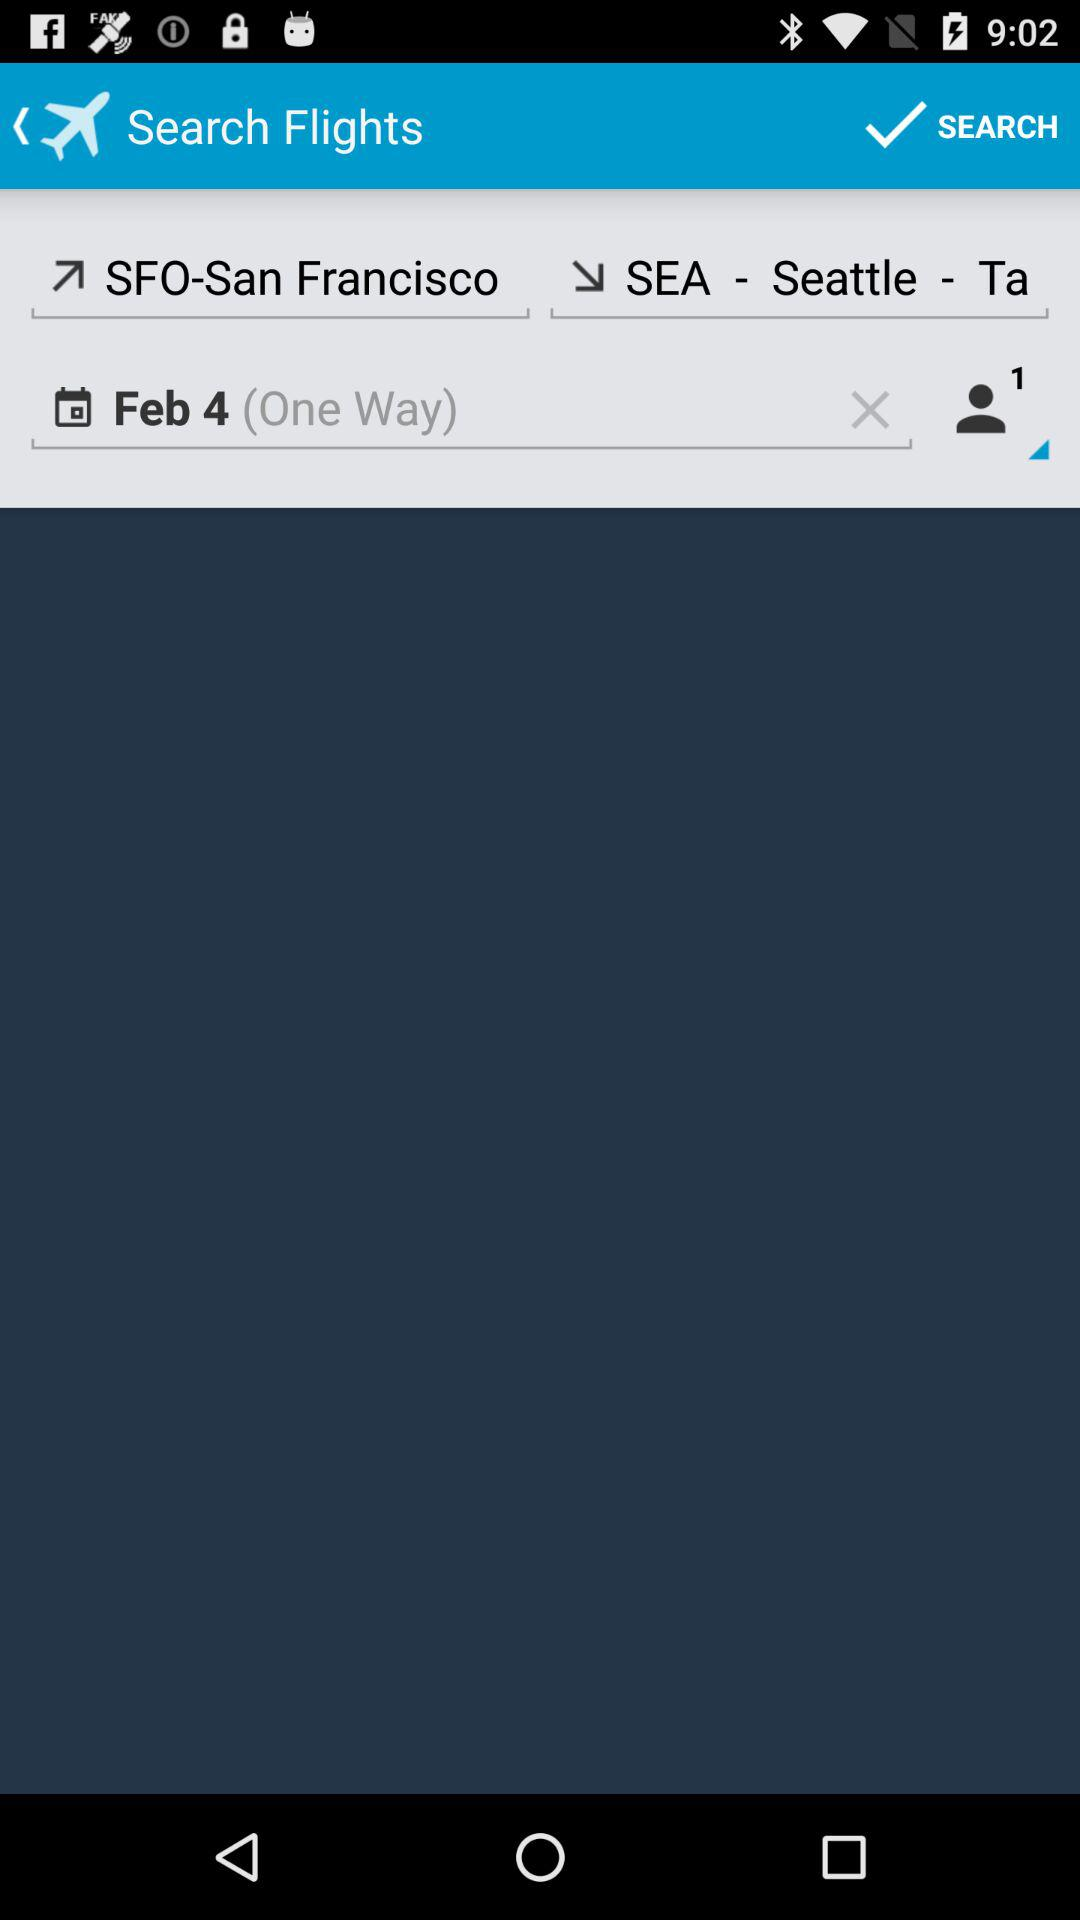What is the departure location? The departure location is San Francisco. 